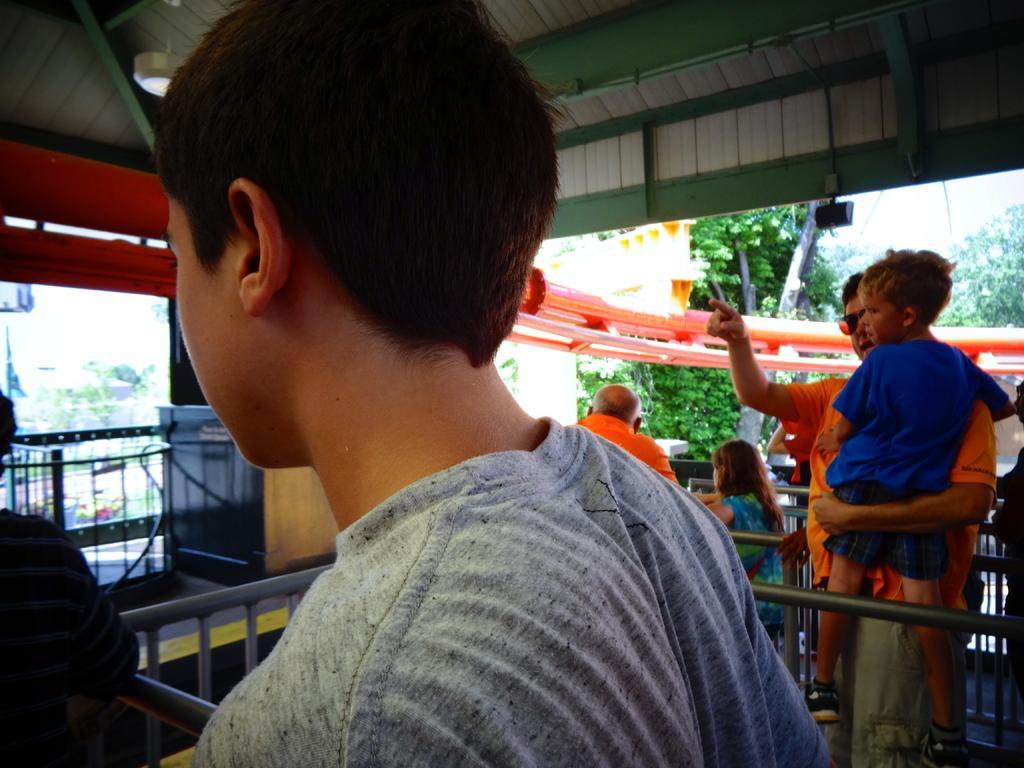Please provide a concise description of this image. In the image there are few persons standing in the front on either side of the grill under roof and on the right side there are trees on the background. 